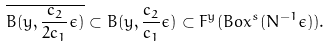Convert formula to latex. <formula><loc_0><loc_0><loc_500><loc_500>\overline { B ( y , \frac { c _ { 2 } } { 2 c _ { 1 } } \epsilon ) } \subset B ( y , \frac { c _ { 2 } } { c _ { 1 } } \epsilon ) \subset F ^ { y } ( B o x ^ { s } ( N ^ { - 1 } \epsilon ) ) .</formula> 